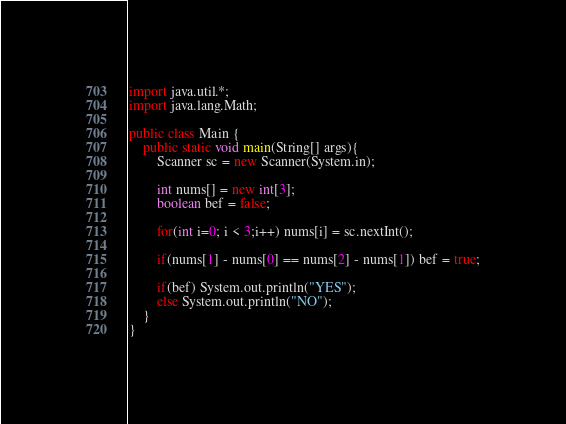Convert code to text. <code><loc_0><loc_0><loc_500><loc_500><_Java_>import java.util.*;
import java.lang.Math;

public class Main {
	public static void main(String[] args){
		Scanner sc = new Scanner(System.in);
  		
      	int nums[] = new int[3];
      	boolean bef = false;
      	
      	for(int i=0; i < 3;i++) nums[i] = sc.nextInt();
      
      	if(nums[1] - nums[0] == nums[2] - nums[1]) bef = true;
      
      	if(bef) System.out.println("YES");
      	else System.out.println("NO");
	}
}
</code> 